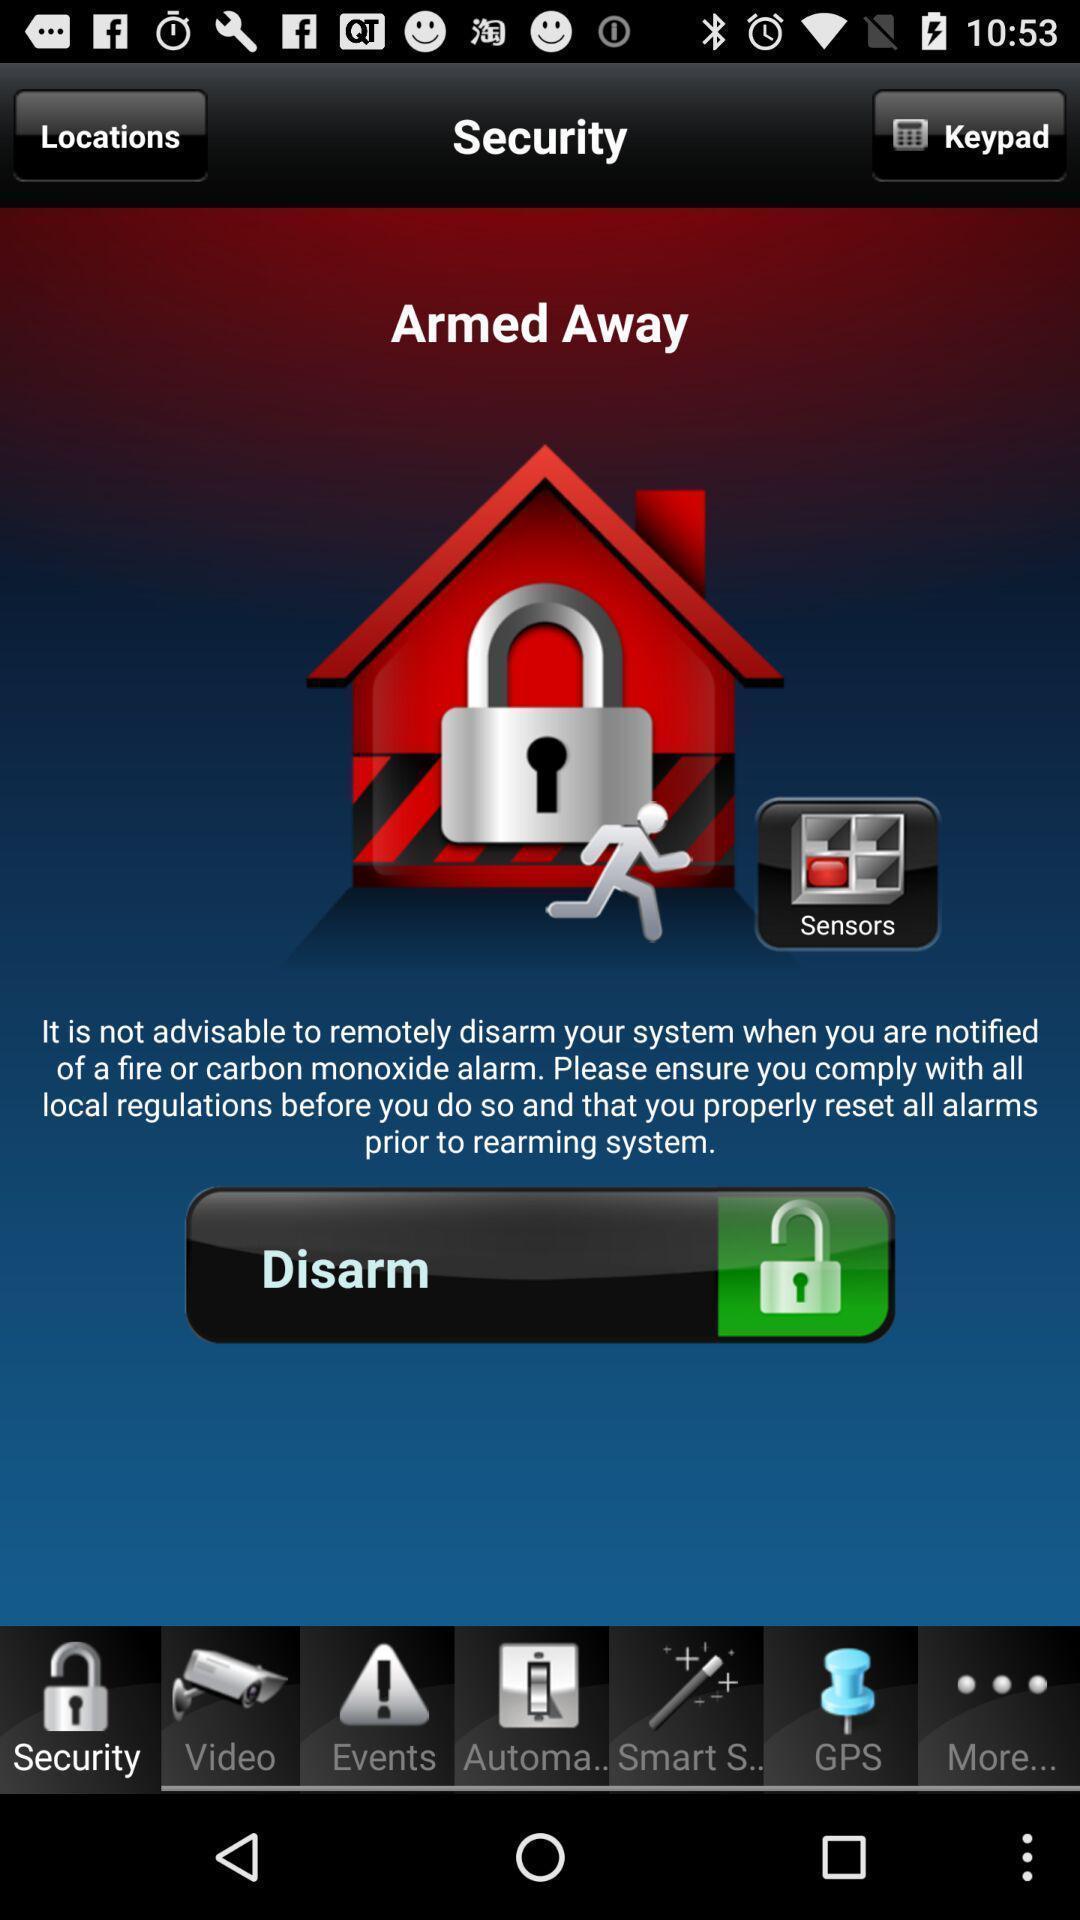Explain what's happening in this screen capture. Security page with instruction of a remote services app. 